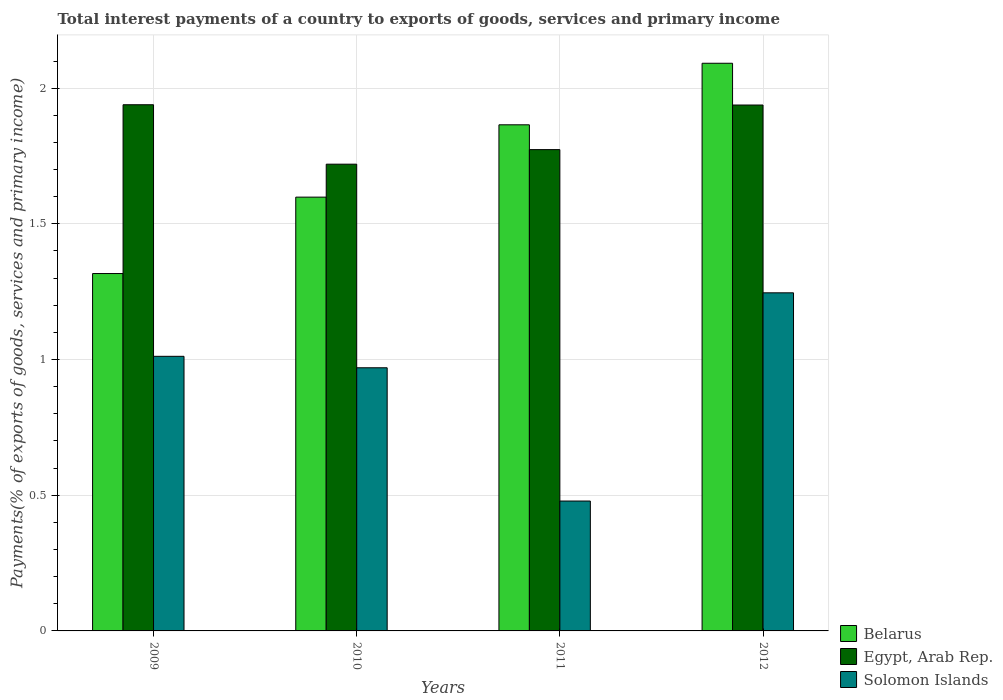How many different coloured bars are there?
Make the answer very short. 3. How many groups of bars are there?
Ensure brevity in your answer.  4. Are the number of bars per tick equal to the number of legend labels?
Make the answer very short. Yes. How many bars are there on the 4th tick from the left?
Provide a short and direct response. 3. How many bars are there on the 4th tick from the right?
Your answer should be compact. 3. What is the label of the 4th group of bars from the left?
Keep it short and to the point. 2012. What is the total interest payments in Solomon Islands in 2011?
Your answer should be compact. 0.48. Across all years, what is the maximum total interest payments in Belarus?
Make the answer very short. 2.09. Across all years, what is the minimum total interest payments in Solomon Islands?
Your response must be concise. 0.48. What is the total total interest payments in Solomon Islands in the graph?
Provide a short and direct response. 3.71. What is the difference between the total interest payments in Belarus in 2009 and that in 2012?
Offer a terse response. -0.77. What is the difference between the total interest payments in Solomon Islands in 2011 and the total interest payments in Belarus in 2010?
Your answer should be compact. -1.12. What is the average total interest payments in Solomon Islands per year?
Your answer should be very brief. 0.93. In the year 2009, what is the difference between the total interest payments in Egypt, Arab Rep. and total interest payments in Solomon Islands?
Provide a short and direct response. 0.93. In how many years, is the total interest payments in Belarus greater than 1.1 %?
Your answer should be very brief. 4. What is the ratio of the total interest payments in Egypt, Arab Rep. in 2011 to that in 2012?
Offer a terse response. 0.92. What is the difference between the highest and the second highest total interest payments in Egypt, Arab Rep.?
Offer a terse response. 0. What is the difference between the highest and the lowest total interest payments in Belarus?
Ensure brevity in your answer.  0.77. What does the 3rd bar from the left in 2009 represents?
Ensure brevity in your answer.  Solomon Islands. What does the 1st bar from the right in 2012 represents?
Make the answer very short. Solomon Islands. Are all the bars in the graph horizontal?
Your answer should be very brief. No. What is the difference between two consecutive major ticks on the Y-axis?
Provide a succinct answer. 0.5. Does the graph contain grids?
Ensure brevity in your answer.  Yes. How many legend labels are there?
Provide a short and direct response. 3. How are the legend labels stacked?
Your answer should be compact. Vertical. What is the title of the graph?
Provide a succinct answer. Total interest payments of a country to exports of goods, services and primary income. Does "Congo (Democratic)" appear as one of the legend labels in the graph?
Your response must be concise. No. What is the label or title of the X-axis?
Ensure brevity in your answer.  Years. What is the label or title of the Y-axis?
Make the answer very short. Payments(% of exports of goods, services and primary income). What is the Payments(% of exports of goods, services and primary income) in Belarus in 2009?
Your answer should be very brief. 1.32. What is the Payments(% of exports of goods, services and primary income) of Egypt, Arab Rep. in 2009?
Provide a succinct answer. 1.94. What is the Payments(% of exports of goods, services and primary income) of Solomon Islands in 2009?
Provide a succinct answer. 1.01. What is the Payments(% of exports of goods, services and primary income) in Belarus in 2010?
Offer a very short reply. 1.6. What is the Payments(% of exports of goods, services and primary income) of Egypt, Arab Rep. in 2010?
Keep it short and to the point. 1.72. What is the Payments(% of exports of goods, services and primary income) of Solomon Islands in 2010?
Give a very brief answer. 0.97. What is the Payments(% of exports of goods, services and primary income) of Belarus in 2011?
Your answer should be compact. 1.86. What is the Payments(% of exports of goods, services and primary income) of Egypt, Arab Rep. in 2011?
Your answer should be compact. 1.77. What is the Payments(% of exports of goods, services and primary income) in Solomon Islands in 2011?
Your response must be concise. 0.48. What is the Payments(% of exports of goods, services and primary income) of Belarus in 2012?
Your answer should be compact. 2.09. What is the Payments(% of exports of goods, services and primary income) in Egypt, Arab Rep. in 2012?
Your answer should be very brief. 1.94. What is the Payments(% of exports of goods, services and primary income) of Solomon Islands in 2012?
Give a very brief answer. 1.25. Across all years, what is the maximum Payments(% of exports of goods, services and primary income) of Belarus?
Your response must be concise. 2.09. Across all years, what is the maximum Payments(% of exports of goods, services and primary income) in Egypt, Arab Rep.?
Offer a very short reply. 1.94. Across all years, what is the maximum Payments(% of exports of goods, services and primary income) in Solomon Islands?
Give a very brief answer. 1.25. Across all years, what is the minimum Payments(% of exports of goods, services and primary income) of Belarus?
Offer a very short reply. 1.32. Across all years, what is the minimum Payments(% of exports of goods, services and primary income) of Egypt, Arab Rep.?
Ensure brevity in your answer.  1.72. Across all years, what is the minimum Payments(% of exports of goods, services and primary income) of Solomon Islands?
Make the answer very short. 0.48. What is the total Payments(% of exports of goods, services and primary income) of Belarus in the graph?
Offer a very short reply. 6.87. What is the total Payments(% of exports of goods, services and primary income) in Egypt, Arab Rep. in the graph?
Ensure brevity in your answer.  7.37. What is the total Payments(% of exports of goods, services and primary income) in Solomon Islands in the graph?
Your response must be concise. 3.71. What is the difference between the Payments(% of exports of goods, services and primary income) of Belarus in 2009 and that in 2010?
Ensure brevity in your answer.  -0.28. What is the difference between the Payments(% of exports of goods, services and primary income) in Egypt, Arab Rep. in 2009 and that in 2010?
Offer a very short reply. 0.22. What is the difference between the Payments(% of exports of goods, services and primary income) of Solomon Islands in 2009 and that in 2010?
Make the answer very short. 0.04. What is the difference between the Payments(% of exports of goods, services and primary income) of Belarus in 2009 and that in 2011?
Ensure brevity in your answer.  -0.55. What is the difference between the Payments(% of exports of goods, services and primary income) in Egypt, Arab Rep. in 2009 and that in 2011?
Provide a short and direct response. 0.17. What is the difference between the Payments(% of exports of goods, services and primary income) in Solomon Islands in 2009 and that in 2011?
Your answer should be very brief. 0.53. What is the difference between the Payments(% of exports of goods, services and primary income) of Belarus in 2009 and that in 2012?
Ensure brevity in your answer.  -0.77. What is the difference between the Payments(% of exports of goods, services and primary income) in Egypt, Arab Rep. in 2009 and that in 2012?
Offer a very short reply. 0. What is the difference between the Payments(% of exports of goods, services and primary income) in Solomon Islands in 2009 and that in 2012?
Keep it short and to the point. -0.23. What is the difference between the Payments(% of exports of goods, services and primary income) in Belarus in 2010 and that in 2011?
Keep it short and to the point. -0.27. What is the difference between the Payments(% of exports of goods, services and primary income) in Egypt, Arab Rep. in 2010 and that in 2011?
Provide a succinct answer. -0.05. What is the difference between the Payments(% of exports of goods, services and primary income) in Solomon Islands in 2010 and that in 2011?
Provide a succinct answer. 0.49. What is the difference between the Payments(% of exports of goods, services and primary income) in Belarus in 2010 and that in 2012?
Make the answer very short. -0.49. What is the difference between the Payments(% of exports of goods, services and primary income) in Egypt, Arab Rep. in 2010 and that in 2012?
Ensure brevity in your answer.  -0.22. What is the difference between the Payments(% of exports of goods, services and primary income) in Solomon Islands in 2010 and that in 2012?
Ensure brevity in your answer.  -0.28. What is the difference between the Payments(% of exports of goods, services and primary income) in Belarus in 2011 and that in 2012?
Your response must be concise. -0.23. What is the difference between the Payments(% of exports of goods, services and primary income) in Egypt, Arab Rep. in 2011 and that in 2012?
Your answer should be compact. -0.16. What is the difference between the Payments(% of exports of goods, services and primary income) of Solomon Islands in 2011 and that in 2012?
Your answer should be very brief. -0.77. What is the difference between the Payments(% of exports of goods, services and primary income) in Belarus in 2009 and the Payments(% of exports of goods, services and primary income) in Egypt, Arab Rep. in 2010?
Offer a terse response. -0.4. What is the difference between the Payments(% of exports of goods, services and primary income) of Belarus in 2009 and the Payments(% of exports of goods, services and primary income) of Solomon Islands in 2010?
Provide a short and direct response. 0.35. What is the difference between the Payments(% of exports of goods, services and primary income) of Egypt, Arab Rep. in 2009 and the Payments(% of exports of goods, services and primary income) of Solomon Islands in 2010?
Provide a short and direct response. 0.97. What is the difference between the Payments(% of exports of goods, services and primary income) of Belarus in 2009 and the Payments(% of exports of goods, services and primary income) of Egypt, Arab Rep. in 2011?
Provide a short and direct response. -0.46. What is the difference between the Payments(% of exports of goods, services and primary income) in Belarus in 2009 and the Payments(% of exports of goods, services and primary income) in Solomon Islands in 2011?
Offer a terse response. 0.84. What is the difference between the Payments(% of exports of goods, services and primary income) of Egypt, Arab Rep. in 2009 and the Payments(% of exports of goods, services and primary income) of Solomon Islands in 2011?
Make the answer very short. 1.46. What is the difference between the Payments(% of exports of goods, services and primary income) of Belarus in 2009 and the Payments(% of exports of goods, services and primary income) of Egypt, Arab Rep. in 2012?
Your answer should be very brief. -0.62. What is the difference between the Payments(% of exports of goods, services and primary income) of Belarus in 2009 and the Payments(% of exports of goods, services and primary income) of Solomon Islands in 2012?
Provide a short and direct response. 0.07. What is the difference between the Payments(% of exports of goods, services and primary income) of Egypt, Arab Rep. in 2009 and the Payments(% of exports of goods, services and primary income) of Solomon Islands in 2012?
Offer a terse response. 0.69. What is the difference between the Payments(% of exports of goods, services and primary income) of Belarus in 2010 and the Payments(% of exports of goods, services and primary income) of Egypt, Arab Rep. in 2011?
Make the answer very short. -0.18. What is the difference between the Payments(% of exports of goods, services and primary income) in Belarus in 2010 and the Payments(% of exports of goods, services and primary income) in Solomon Islands in 2011?
Your response must be concise. 1.12. What is the difference between the Payments(% of exports of goods, services and primary income) of Egypt, Arab Rep. in 2010 and the Payments(% of exports of goods, services and primary income) of Solomon Islands in 2011?
Provide a short and direct response. 1.24. What is the difference between the Payments(% of exports of goods, services and primary income) of Belarus in 2010 and the Payments(% of exports of goods, services and primary income) of Egypt, Arab Rep. in 2012?
Provide a short and direct response. -0.34. What is the difference between the Payments(% of exports of goods, services and primary income) of Belarus in 2010 and the Payments(% of exports of goods, services and primary income) of Solomon Islands in 2012?
Your response must be concise. 0.35. What is the difference between the Payments(% of exports of goods, services and primary income) of Egypt, Arab Rep. in 2010 and the Payments(% of exports of goods, services and primary income) of Solomon Islands in 2012?
Offer a very short reply. 0.47. What is the difference between the Payments(% of exports of goods, services and primary income) in Belarus in 2011 and the Payments(% of exports of goods, services and primary income) in Egypt, Arab Rep. in 2012?
Your answer should be compact. -0.07. What is the difference between the Payments(% of exports of goods, services and primary income) in Belarus in 2011 and the Payments(% of exports of goods, services and primary income) in Solomon Islands in 2012?
Provide a short and direct response. 0.62. What is the difference between the Payments(% of exports of goods, services and primary income) of Egypt, Arab Rep. in 2011 and the Payments(% of exports of goods, services and primary income) of Solomon Islands in 2012?
Provide a short and direct response. 0.53. What is the average Payments(% of exports of goods, services and primary income) in Belarus per year?
Your answer should be compact. 1.72. What is the average Payments(% of exports of goods, services and primary income) in Egypt, Arab Rep. per year?
Provide a succinct answer. 1.84. What is the average Payments(% of exports of goods, services and primary income) of Solomon Islands per year?
Offer a terse response. 0.93. In the year 2009, what is the difference between the Payments(% of exports of goods, services and primary income) in Belarus and Payments(% of exports of goods, services and primary income) in Egypt, Arab Rep.?
Give a very brief answer. -0.62. In the year 2009, what is the difference between the Payments(% of exports of goods, services and primary income) in Belarus and Payments(% of exports of goods, services and primary income) in Solomon Islands?
Keep it short and to the point. 0.31. In the year 2009, what is the difference between the Payments(% of exports of goods, services and primary income) of Egypt, Arab Rep. and Payments(% of exports of goods, services and primary income) of Solomon Islands?
Ensure brevity in your answer.  0.93. In the year 2010, what is the difference between the Payments(% of exports of goods, services and primary income) of Belarus and Payments(% of exports of goods, services and primary income) of Egypt, Arab Rep.?
Give a very brief answer. -0.12. In the year 2010, what is the difference between the Payments(% of exports of goods, services and primary income) in Belarus and Payments(% of exports of goods, services and primary income) in Solomon Islands?
Make the answer very short. 0.63. In the year 2010, what is the difference between the Payments(% of exports of goods, services and primary income) in Egypt, Arab Rep. and Payments(% of exports of goods, services and primary income) in Solomon Islands?
Provide a short and direct response. 0.75. In the year 2011, what is the difference between the Payments(% of exports of goods, services and primary income) in Belarus and Payments(% of exports of goods, services and primary income) in Egypt, Arab Rep.?
Your response must be concise. 0.09. In the year 2011, what is the difference between the Payments(% of exports of goods, services and primary income) in Belarus and Payments(% of exports of goods, services and primary income) in Solomon Islands?
Your response must be concise. 1.39. In the year 2011, what is the difference between the Payments(% of exports of goods, services and primary income) of Egypt, Arab Rep. and Payments(% of exports of goods, services and primary income) of Solomon Islands?
Provide a succinct answer. 1.29. In the year 2012, what is the difference between the Payments(% of exports of goods, services and primary income) of Belarus and Payments(% of exports of goods, services and primary income) of Egypt, Arab Rep.?
Your answer should be very brief. 0.15. In the year 2012, what is the difference between the Payments(% of exports of goods, services and primary income) of Belarus and Payments(% of exports of goods, services and primary income) of Solomon Islands?
Provide a short and direct response. 0.85. In the year 2012, what is the difference between the Payments(% of exports of goods, services and primary income) in Egypt, Arab Rep. and Payments(% of exports of goods, services and primary income) in Solomon Islands?
Keep it short and to the point. 0.69. What is the ratio of the Payments(% of exports of goods, services and primary income) in Belarus in 2009 to that in 2010?
Make the answer very short. 0.82. What is the ratio of the Payments(% of exports of goods, services and primary income) of Egypt, Arab Rep. in 2009 to that in 2010?
Offer a terse response. 1.13. What is the ratio of the Payments(% of exports of goods, services and primary income) of Solomon Islands in 2009 to that in 2010?
Your answer should be compact. 1.04. What is the ratio of the Payments(% of exports of goods, services and primary income) in Belarus in 2009 to that in 2011?
Offer a terse response. 0.71. What is the ratio of the Payments(% of exports of goods, services and primary income) of Egypt, Arab Rep. in 2009 to that in 2011?
Offer a terse response. 1.09. What is the ratio of the Payments(% of exports of goods, services and primary income) in Solomon Islands in 2009 to that in 2011?
Offer a very short reply. 2.11. What is the ratio of the Payments(% of exports of goods, services and primary income) of Belarus in 2009 to that in 2012?
Make the answer very short. 0.63. What is the ratio of the Payments(% of exports of goods, services and primary income) of Egypt, Arab Rep. in 2009 to that in 2012?
Provide a short and direct response. 1. What is the ratio of the Payments(% of exports of goods, services and primary income) of Solomon Islands in 2009 to that in 2012?
Offer a terse response. 0.81. What is the ratio of the Payments(% of exports of goods, services and primary income) of Belarus in 2010 to that in 2011?
Make the answer very short. 0.86. What is the ratio of the Payments(% of exports of goods, services and primary income) of Egypt, Arab Rep. in 2010 to that in 2011?
Offer a very short reply. 0.97. What is the ratio of the Payments(% of exports of goods, services and primary income) in Solomon Islands in 2010 to that in 2011?
Offer a terse response. 2.03. What is the ratio of the Payments(% of exports of goods, services and primary income) in Belarus in 2010 to that in 2012?
Offer a very short reply. 0.76. What is the ratio of the Payments(% of exports of goods, services and primary income) in Egypt, Arab Rep. in 2010 to that in 2012?
Offer a terse response. 0.89. What is the ratio of the Payments(% of exports of goods, services and primary income) of Solomon Islands in 2010 to that in 2012?
Offer a very short reply. 0.78. What is the ratio of the Payments(% of exports of goods, services and primary income) in Belarus in 2011 to that in 2012?
Give a very brief answer. 0.89. What is the ratio of the Payments(% of exports of goods, services and primary income) in Egypt, Arab Rep. in 2011 to that in 2012?
Your answer should be compact. 0.92. What is the ratio of the Payments(% of exports of goods, services and primary income) of Solomon Islands in 2011 to that in 2012?
Keep it short and to the point. 0.38. What is the difference between the highest and the second highest Payments(% of exports of goods, services and primary income) of Belarus?
Your answer should be very brief. 0.23. What is the difference between the highest and the second highest Payments(% of exports of goods, services and primary income) in Egypt, Arab Rep.?
Your answer should be compact. 0. What is the difference between the highest and the second highest Payments(% of exports of goods, services and primary income) in Solomon Islands?
Your answer should be very brief. 0.23. What is the difference between the highest and the lowest Payments(% of exports of goods, services and primary income) of Belarus?
Provide a short and direct response. 0.77. What is the difference between the highest and the lowest Payments(% of exports of goods, services and primary income) of Egypt, Arab Rep.?
Give a very brief answer. 0.22. What is the difference between the highest and the lowest Payments(% of exports of goods, services and primary income) in Solomon Islands?
Provide a short and direct response. 0.77. 